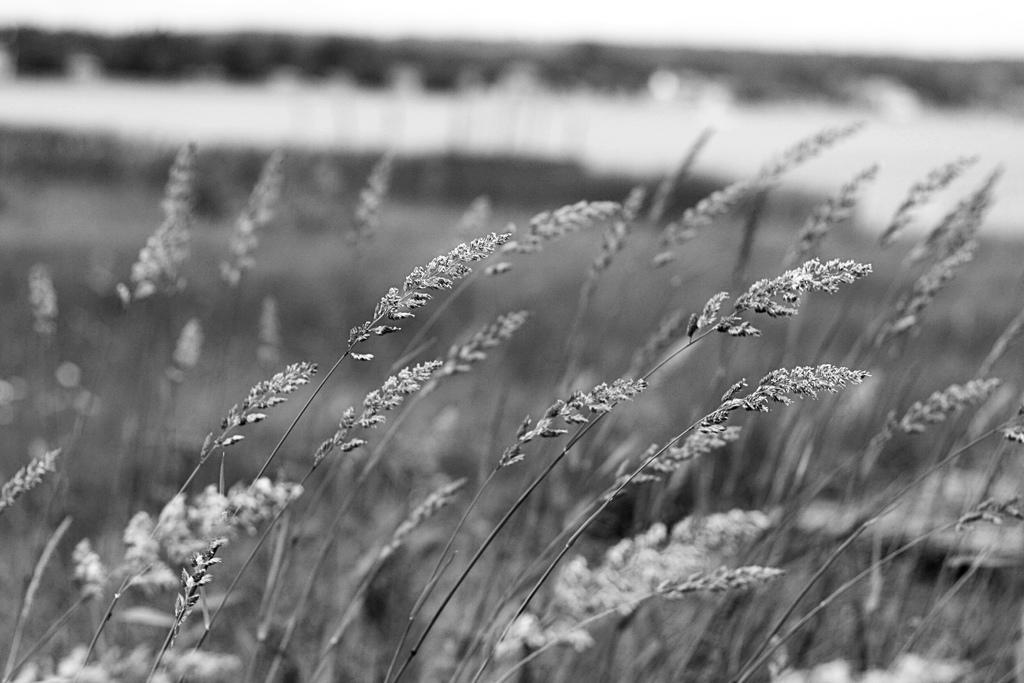How would you summarize this image in a sentence or two? This is a black and white image. We can see some plants and the blurred background. 